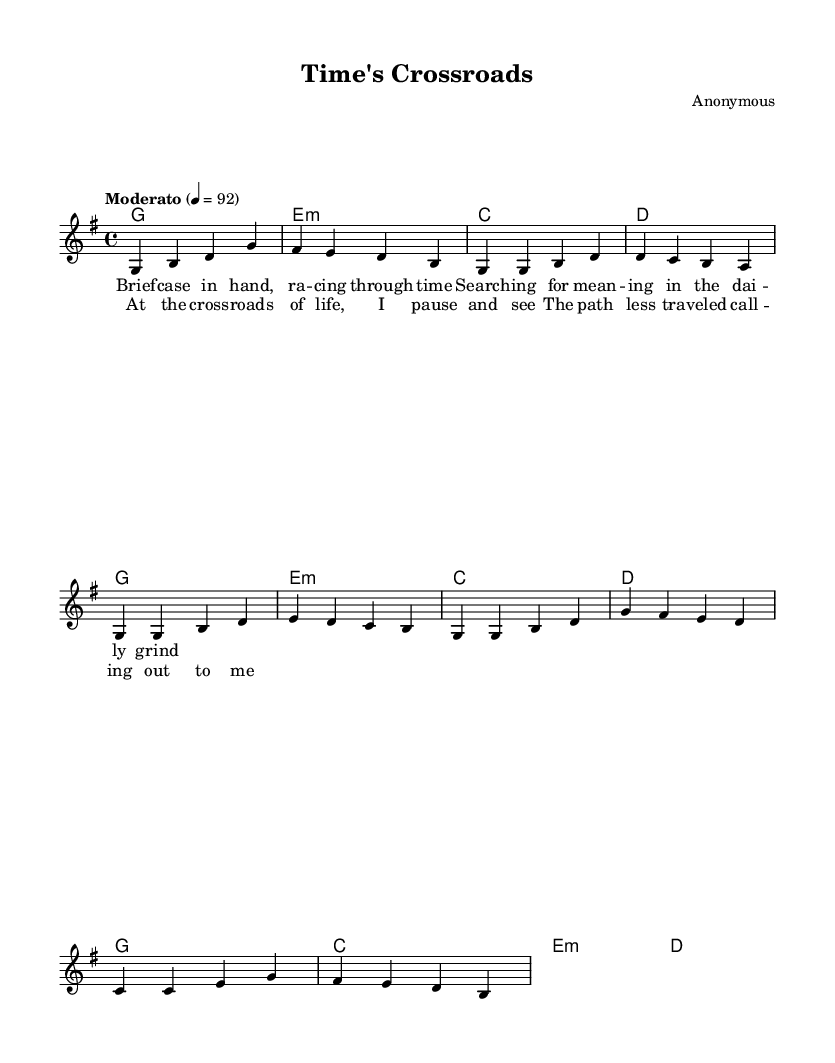What is the key signature of this music? The key signature is G major, which has one sharp (F#). You can determine this by looking for any sharps or flats at the beginning of the staff.
Answer: G major What is the time signature of this music? The time signature is 4/4, indicated at the beginning of the sheet music. It shows that there are four beats in each measure and the quarter note gets one beat.
Answer: 4/4 What is the tempo marking of this music? The tempo marking indicates "Moderato," which suggests a moderate speed. This is noted in the tempo indication (4 = 92) at the beginning, where 92 refers to the beats per minute.
Answer: Moderato How many measures are in the chorus section? The chorus section consists of four measures based on the layout of the chorus lyrics and corresponding melody. Each line of music typically represents one measure in this context.
Answer: 4 What is the starting chord of the piece? The piece starts with a G major chord, as indicated at the beginning of the harmonies section. It is the first chord noted in the chord progression.
Answer: G What is repeated in the chorus? The phrase "the path less traveled calling out to me" is repeated in the chorus, reinforcing the theme of self-discovery and reflection on life's choices. You can identify this as it recurs verbatim in the written lyrics.
Answer: The path less traveled calling out to me What type of song is "Time's Crossroads"? "Time's Crossroads" is an acoustic folk song, characterized by its focus on themes of self-discovery and life transitions, as reflected in its lyrics and style. The overall feel of the song aligns with typical acoustic folk music themes.
Answer: Acoustic folk 